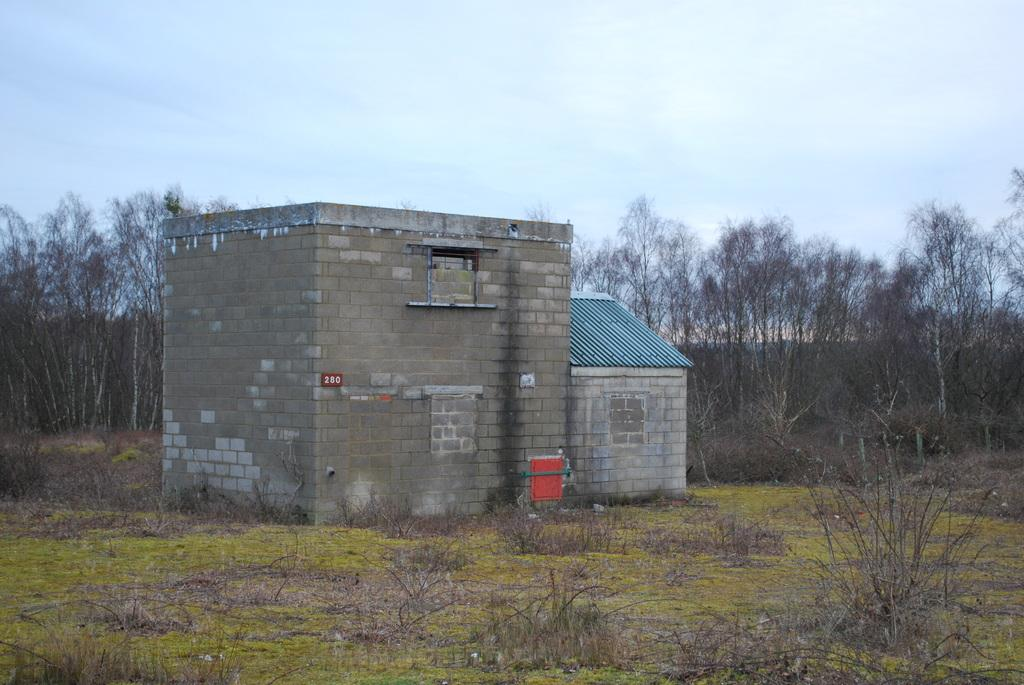What type of vegetation is present on the ground in the image? There is grass and plants on the ground in the image. What is the material of the building's wall? The building has a brick wall. What can be seen in the background of the image? There are trees and the sky visible in the background. Can you see any animals in the image? There are no animals visible in the image. Is the building on fire in the image? There is no indication of a fire or burning in the image. 